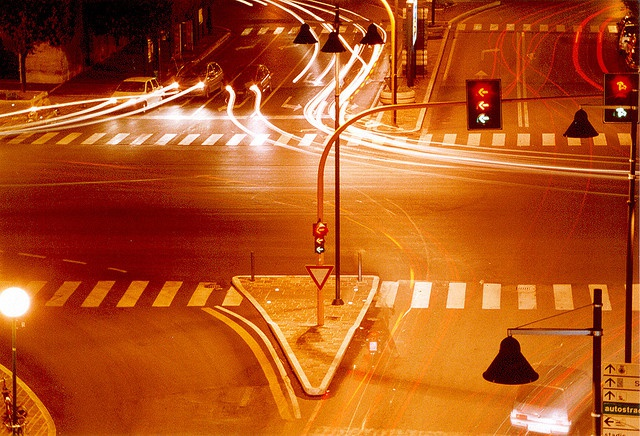Describe the objects in this image and their specific colors. I can see car in black, red, white, and tan tones, traffic light in black, maroon, and brown tones, traffic light in black, maroon, and brown tones, car in black, maroon, red, and white tones, and car in black, white, maroon, and orange tones in this image. 